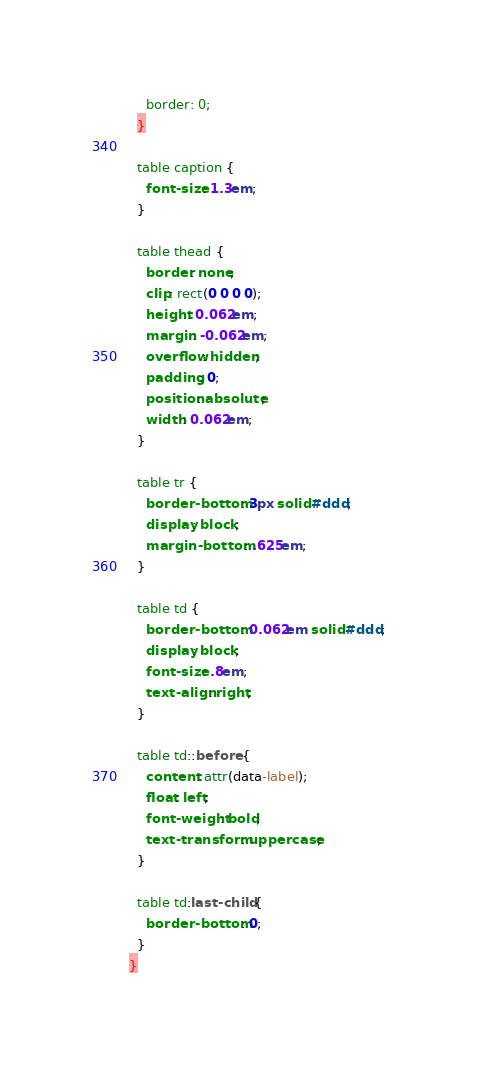Convert code to text. <code><loc_0><loc_0><loc_500><loc_500><_CSS_>    border: 0;
  }

  table caption {
    font-size: 1.3em;
  }

  table thead {
    border: none;
    clip: rect(0 0 0 0);
    height: 0.062em;
    margin: -0.062em;
    overflow: hidden;
    padding: 0;
    position: absolute;
    width: 0.062em;
  }

  table tr {
    border-bottom: 3px solid #ddd;
    display: block;
    margin-bottom: .625em;
  }

  table td {
    border-bottom: 0.062em solid #ddd;
    display: block;
    font-size: .8em;
    text-align: right;
  }

  table td::before {
    content: attr(data-label);
    float: left;
    font-weight: bold;
    text-transform: uppercase;
  }

  table td:last-child {
    border-bottom: 0;
  }
}
</code> 